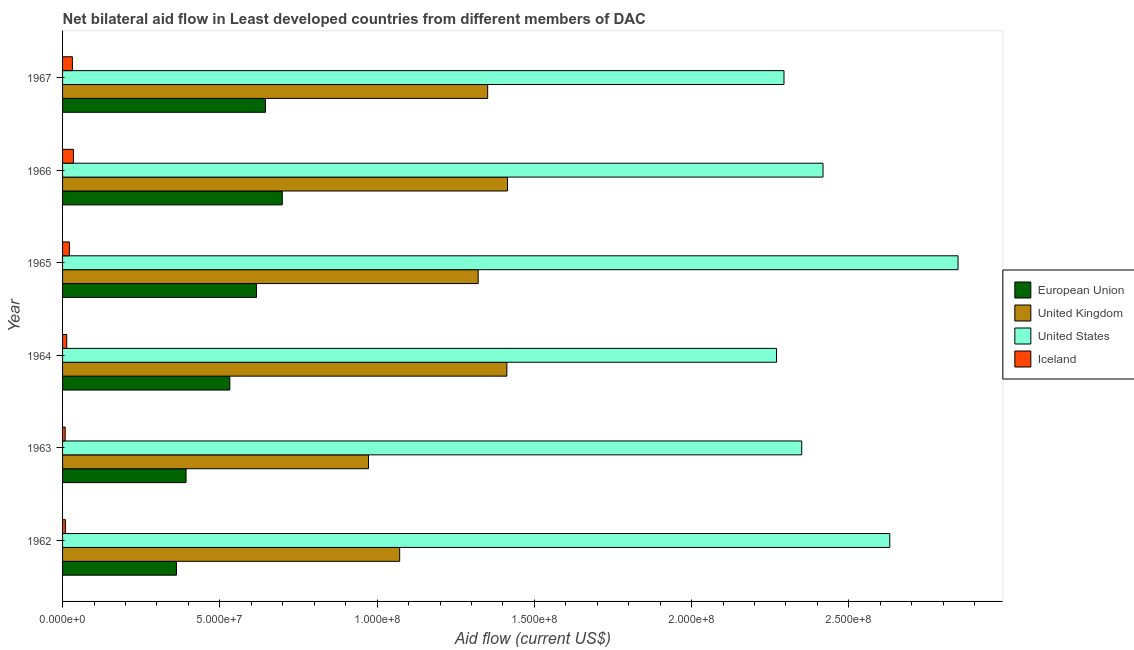How many groups of bars are there?
Make the answer very short. 6. What is the label of the 1st group of bars from the top?
Your answer should be very brief. 1967. In how many cases, is the number of bars for a given year not equal to the number of legend labels?
Make the answer very short. 0. What is the amount of aid given by uk in 1965?
Your response must be concise. 1.32e+08. Across all years, what is the maximum amount of aid given by eu?
Provide a short and direct response. 6.99e+07. Across all years, what is the minimum amount of aid given by iceland?
Make the answer very short. 8.30e+05. In which year was the amount of aid given by us maximum?
Give a very brief answer. 1965. In which year was the amount of aid given by iceland minimum?
Your answer should be very brief. 1963. What is the total amount of aid given by uk in the graph?
Your answer should be compact. 7.54e+08. What is the difference between the amount of aid given by uk in 1963 and that in 1967?
Give a very brief answer. -3.79e+07. What is the difference between the amount of aid given by us in 1965 and the amount of aid given by eu in 1963?
Give a very brief answer. 2.45e+08. What is the average amount of aid given by us per year?
Provide a succinct answer. 2.47e+08. In the year 1962, what is the difference between the amount of aid given by uk and amount of aid given by eu?
Your answer should be very brief. 7.10e+07. In how many years, is the amount of aid given by uk greater than 200000000 US$?
Your response must be concise. 0. What is the ratio of the amount of aid given by iceland in 1964 to that in 1967?
Offer a very short reply. 0.43. Is the amount of aid given by iceland in 1963 less than that in 1964?
Give a very brief answer. Yes. What is the difference between the highest and the second highest amount of aid given by eu?
Your answer should be very brief. 5.35e+06. What is the difference between the highest and the lowest amount of aid given by eu?
Provide a succinct answer. 3.36e+07. In how many years, is the amount of aid given by iceland greater than the average amount of aid given by iceland taken over all years?
Keep it short and to the point. 3. Is the sum of the amount of aid given by iceland in 1963 and 1967 greater than the maximum amount of aid given by uk across all years?
Your response must be concise. No. What does the 2nd bar from the top in 1967 represents?
Your answer should be compact. United States. Is it the case that in every year, the sum of the amount of aid given by eu and amount of aid given by uk is greater than the amount of aid given by us?
Provide a short and direct response. No. Are all the bars in the graph horizontal?
Give a very brief answer. Yes. What is the difference between two consecutive major ticks on the X-axis?
Make the answer very short. 5.00e+07. Does the graph contain any zero values?
Your response must be concise. No. Where does the legend appear in the graph?
Your answer should be compact. Center right. How many legend labels are there?
Keep it short and to the point. 4. How are the legend labels stacked?
Your answer should be very brief. Vertical. What is the title of the graph?
Make the answer very short. Net bilateral aid flow in Least developed countries from different members of DAC. Does "UNHCR" appear as one of the legend labels in the graph?
Provide a succinct answer. No. What is the Aid flow (current US$) in European Union in 1962?
Your response must be concise. 3.62e+07. What is the Aid flow (current US$) of United Kingdom in 1962?
Make the answer very short. 1.07e+08. What is the Aid flow (current US$) of United States in 1962?
Make the answer very short. 2.63e+08. What is the Aid flow (current US$) in European Union in 1963?
Provide a succinct answer. 3.93e+07. What is the Aid flow (current US$) in United Kingdom in 1963?
Provide a short and direct response. 9.73e+07. What is the Aid flow (current US$) of United States in 1963?
Provide a short and direct response. 2.35e+08. What is the Aid flow (current US$) of Iceland in 1963?
Keep it short and to the point. 8.30e+05. What is the Aid flow (current US$) in European Union in 1964?
Your answer should be very brief. 5.32e+07. What is the Aid flow (current US$) in United Kingdom in 1964?
Ensure brevity in your answer.  1.41e+08. What is the Aid flow (current US$) in United States in 1964?
Make the answer very short. 2.27e+08. What is the Aid flow (current US$) in Iceland in 1964?
Your answer should be compact. 1.33e+06. What is the Aid flow (current US$) of European Union in 1965?
Offer a terse response. 6.16e+07. What is the Aid flow (current US$) in United Kingdom in 1965?
Offer a terse response. 1.32e+08. What is the Aid flow (current US$) in United States in 1965?
Make the answer very short. 2.85e+08. What is the Aid flow (current US$) in Iceland in 1965?
Your response must be concise. 2.18e+06. What is the Aid flow (current US$) in European Union in 1966?
Ensure brevity in your answer.  6.99e+07. What is the Aid flow (current US$) of United Kingdom in 1966?
Keep it short and to the point. 1.41e+08. What is the Aid flow (current US$) in United States in 1966?
Your answer should be very brief. 2.42e+08. What is the Aid flow (current US$) in Iceland in 1966?
Make the answer very short. 3.46e+06. What is the Aid flow (current US$) of European Union in 1967?
Give a very brief answer. 6.45e+07. What is the Aid flow (current US$) in United Kingdom in 1967?
Give a very brief answer. 1.35e+08. What is the Aid flow (current US$) of United States in 1967?
Offer a terse response. 2.29e+08. What is the Aid flow (current US$) in Iceland in 1967?
Your answer should be very brief. 3.12e+06. Across all years, what is the maximum Aid flow (current US$) of European Union?
Offer a very short reply. 6.99e+07. Across all years, what is the maximum Aid flow (current US$) in United Kingdom?
Offer a terse response. 1.41e+08. Across all years, what is the maximum Aid flow (current US$) in United States?
Offer a terse response. 2.85e+08. Across all years, what is the maximum Aid flow (current US$) of Iceland?
Make the answer very short. 3.46e+06. Across all years, what is the minimum Aid flow (current US$) of European Union?
Make the answer very short. 3.62e+07. Across all years, what is the minimum Aid flow (current US$) of United Kingdom?
Provide a short and direct response. 9.73e+07. Across all years, what is the minimum Aid flow (current US$) in United States?
Offer a very short reply. 2.27e+08. Across all years, what is the minimum Aid flow (current US$) in Iceland?
Provide a succinct answer. 8.30e+05. What is the total Aid flow (current US$) in European Union in the graph?
Keep it short and to the point. 3.25e+08. What is the total Aid flow (current US$) of United Kingdom in the graph?
Your answer should be very brief. 7.54e+08. What is the total Aid flow (current US$) in United States in the graph?
Offer a very short reply. 1.48e+09. What is the total Aid flow (current US$) of Iceland in the graph?
Your answer should be compact. 1.18e+07. What is the difference between the Aid flow (current US$) in European Union in 1962 and that in 1963?
Your answer should be compact. -3.05e+06. What is the difference between the Aid flow (current US$) in United Kingdom in 1962 and that in 1963?
Your answer should be very brief. 9.91e+06. What is the difference between the Aid flow (current US$) of United States in 1962 and that in 1963?
Provide a short and direct response. 2.80e+07. What is the difference between the Aid flow (current US$) of Iceland in 1962 and that in 1963?
Provide a succinct answer. 7.00e+04. What is the difference between the Aid flow (current US$) in European Union in 1962 and that in 1964?
Offer a terse response. -1.70e+07. What is the difference between the Aid flow (current US$) in United Kingdom in 1962 and that in 1964?
Your answer should be compact. -3.41e+07. What is the difference between the Aid flow (current US$) of United States in 1962 and that in 1964?
Offer a very short reply. 3.60e+07. What is the difference between the Aid flow (current US$) of Iceland in 1962 and that in 1964?
Offer a very short reply. -4.30e+05. What is the difference between the Aid flow (current US$) of European Union in 1962 and that in 1965?
Provide a succinct answer. -2.54e+07. What is the difference between the Aid flow (current US$) of United Kingdom in 1962 and that in 1965?
Offer a very short reply. -2.50e+07. What is the difference between the Aid flow (current US$) in United States in 1962 and that in 1965?
Offer a very short reply. -2.17e+07. What is the difference between the Aid flow (current US$) in Iceland in 1962 and that in 1965?
Ensure brevity in your answer.  -1.28e+06. What is the difference between the Aid flow (current US$) in European Union in 1962 and that in 1966?
Your response must be concise. -3.36e+07. What is the difference between the Aid flow (current US$) in United Kingdom in 1962 and that in 1966?
Keep it short and to the point. -3.43e+07. What is the difference between the Aid flow (current US$) of United States in 1962 and that in 1966?
Your answer should be very brief. 2.12e+07. What is the difference between the Aid flow (current US$) of Iceland in 1962 and that in 1966?
Make the answer very short. -2.56e+06. What is the difference between the Aid flow (current US$) of European Union in 1962 and that in 1967?
Give a very brief answer. -2.83e+07. What is the difference between the Aid flow (current US$) in United Kingdom in 1962 and that in 1967?
Your answer should be compact. -2.80e+07. What is the difference between the Aid flow (current US$) in United States in 1962 and that in 1967?
Make the answer very short. 3.36e+07. What is the difference between the Aid flow (current US$) in Iceland in 1962 and that in 1967?
Your answer should be very brief. -2.22e+06. What is the difference between the Aid flow (current US$) in European Union in 1963 and that in 1964?
Offer a terse response. -1.39e+07. What is the difference between the Aid flow (current US$) of United Kingdom in 1963 and that in 1964?
Provide a short and direct response. -4.40e+07. What is the difference between the Aid flow (current US$) in Iceland in 1963 and that in 1964?
Give a very brief answer. -5.00e+05. What is the difference between the Aid flow (current US$) of European Union in 1963 and that in 1965?
Offer a very short reply. -2.24e+07. What is the difference between the Aid flow (current US$) in United Kingdom in 1963 and that in 1965?
Offer a terse response. -3.49e+07. What is the difference between the Aid flow (current US$) in United States in 1963 and that in 1965?
Make the answer very short. -4.97e+07. What is the difference between the Aid flow (current US$) of Iceland in 1963 and that in 1965?
Offer a terse response. -1.35e+06. What is the difference between the Aid flow (current US$) in European Union in 1963 and that in 1966?
Your answer should be very brief. -3.06e+07. What is the difference between the Aid flow (current US$) of United Kingdom in 1963 and that in 1966?
Your answer should be compact. -4.42e+07. What is the difference between the Aid flow (current US$) in United States in 1963 and that in 1966?
Give a very brief answer. -6.78e+06. What is the difference between the Aid flow (current US$) of Iceland in 1963 and that in 1966?
Provide a succinct answer. -2.63e+06. What is the difference between the Aid flow (current US$) of European Union in 1963 and that in 1967?
Provide a short and direct response. -2.52e+07. What is the difference between the Aid flow (current US$) of United Kingdom in 1963 and that in 1967?
Your answer should be compact. -3.79e+07. What is the difference between the Aid flow (current US$) in United States in 1963 and that in 1967?
Provide a short and direct response. 5.63e+06. What is the difference between the Aid flow (current US$) in Iceland in 1963 and that in 1967?
Ensure brevity in your answer.  -2.29e+06. What is the difference between the Aid flow (current US$) in European Union in 1964 and that in 1965?
Your response must be concise. -8.46e+06. What is the difference between the Aid flow (current US$) of United Kingdom in 1964 and that in 1965?
Your response must be concise. 9.12e+06. What is the difference between the Aid flow (current US$) in United States in 1964 and that in 1965?
Make the answer very short. -5.77e+07. What is the difference between the Aid flow (current US$) in Iceland in 1964 and that in 1965?
Provide a succinct answer. -8.50e+05. What is the difference between the Aid flow (current US$) in European Union in 1964 and that in 1966?
Provide a short and direct response. -1.67e+07. What is the difference between the Aid flow (current US$) in United States in 1964 and that in 1966?
Your response must be concise. -1.48e+07. What is the difference between the Aid flow (current US$) of Iceland in 1964 and that in 1966?
Give a very brief answer. -2.13e+06. What is the difference between the Aid flow (current US$) in European Union in 1964 and that in 1967?
Give a very brief answer. -1.13e+07. What is the difference between the Aid flow (current US$) of United Kingdom in 1964 and that in 1967?
Ensure brevity in your answer.  6.10e+06. What is the difference between the Aid flow (current US$) in United States in 1964 and that in 1967?
Your answer should be compact. -2.37e+06. What is the difference between the Aid flow (current US$) in Iceland in 1964 and that in 1967?
Ensure brevity in your answer.  -1.79e+06. What is the difference between the Aid flow (current US$) of European Union in 1965 and that in 1966?
Your answer should be very brief. -8.22e+06. What is the difference between the Aid flow (current US$) in United Kingdom in 1965 and that in 1966?
Provide a succinct answer. -9.33e+06. What is the difference between the Aid flow (current US$) of United States in 1965 and that in 1966?
Offer a very short reply. 4.29e+07. What is the difference between the Aid flow (current US$) in Iceland in 1965 and that in 1966?
Provide a short and direct response. -1.28e+06. What is the difference between the Aid flow (current US$) in European Union in 1965 and that in 1967?
Your response must be concise. -2.87e+06. What is the difference between the Aid flow (current US$) of United Kingdom in 1965 and that in 1967?
Ensure brevity in your answer.  -3.02e+06. What is the difference between the Aid flow (current US$) of United States in 1965 and that in 1967?
Give a very brief answer. 5.53e+07. What is the difference between the Aid flow (current US$) of Iceland in 1965 and that in 1967?
Offer a terse response. -9.40e+05. What is the difference between the Aid flow (current US$) in European Union in 1966 and that in 1967?
Keep it short and to the point. 5.35e+06. What is the difference between the Aid flow (current US$) in United Kingdom in 1966 and that in 1967?
Provide a short and direct response. 6.31e+06. What is the difference between the Aid flow (current US$) of United States in 1966 and that in 1967?
Your response must be concise. 1.24e+07. What is the difference between the Aid flow (current US$) of European Union in 1962 and the Aid flow (current US$) of United Kingdom in 1963?
Ensure brevity in your answer.  -6.11e+07. What is the difference between the Aid flow (current US$) in European Union in 1962 and the Aid flow (current US$) in United States in 1963?
Ensure brevity in your answer.  -1.99e+08. What is the difference between the Aid flow (current US$) in European Union in 1962 and the Aid flow (current US$) in Iceland in 1963?
Your answer should be compact. 3.54e+07. What is the difference between the Aid flow (current US$) of United Kingdom in 1962 and the Aid flow (current US$) of United States in 1963?
Ensure brevity in your answer.  -1.28e+08. What is the difference between the Aid flow (current US$) in United Kingdom in 1962 and the Aid flow (current US$) in Iceland in 1963?
Provide a succinct answer. 1.06e+08. What is the difference between the Aid flow (current US$) of United States in 1962 and the Aid flow (current US$) of Iceland in 1963?
Keep it short and to the point. 2.62e+08. What is the difference between the Aid flow (current US$) in European Union in 1962 and the Aid flow (current US$) in United Kingdom in 1964?
Give a very brief answer. -1.05e+08. What is the difference between the Aid flow (current US$) of European Union in 1962 and the Aid flow (current US$) of United States in 1964?
Give a very brief answer. -1.91e+08. What is the difference between the Aid flow (current US$) in European Union in 1962 and the Aid flow (current US$) in Iceland in 1964?
Your answer should be very brief. 3.49e+07. What is the difference between the Aid flow (current US$) in United Kingdom in 1962 and the Aid flow (current US$) in United States in 1964?
Provide a short and direct response. -1.20e+08. What is the difference between the Aid flow (current US$) of United Kingdom in 1962 and the Aid flow (current US$) of Iceland in 1964?
Keep it short and to the point. 1.06e+08. What is the difference between the Aid flow (current US$) in United States in 1962 and the Aid flow (current US$) in Iceland in 1964?
Your response must be concise. 2.62e+08. What is the difference between the Aid flow (current US$) in European Union in 1962 and the Aid flow (current US$) in United Kingdom in 1965?
Provide a succinct answer. -9.59e+07. What is the difference between the Aid flow (current US$) of European Union in 1962 and the Aid flow (current US$) of United States in 1965?
Your answer should be very brief. -2.48e+08. What is the difference between the Aid flow (current US$) in European Union in 1962 and the Aid flow (current US$) in Iceland in 1965?
Offer a very short reply. 3.40e+07. What is the difference between the Aid flow (current US$) in United Kingdom in 1962 and the Aid flow (current US$) in United States in 1965?
Your response must be concise. -1.78e+08. What is the difference between the Aid flow (current US$) in United Kingdom in 1962 and the Aid flow (current US$) in Iceland in 1965?
Your answer should be very brief. 1.05e+08. What is the difference between the Aid flow (current US$) of United States in 1962 and the Aid flow (current US$) of Iceland in 1965?
Make the answer very short. 2.61e+08. What is the difference between the Aid flow (current US$) in European Union in 1962 and the Aid flow (current US$) in United Kingdom in 1966?
Provide a short and direct response. -1.05e+08. What is the difference between the Aid flow (current US$) of European Union in 1962 and the Aid flow (current US$) of United States in 1966?
Ensure brevity in your answer.  -2.06e+08. What is the difference between the Aid flow (current US$) of European Union in 1962 and the Aid flow (current US$) of Iceland in 1966?
Provide a succinct answer. 3.28e+07. What is the difference between the Aid flow (current US$) in United Kingdom in 1962 and the Aid flow (current US$) in United States in 1966?
Offer a terse response. -1.35e+08. What is the difference between the Aid flow (current US$) of United Kingdom in 1962 and the Aid flow (current US$) of Iceland in 1966?
Provide a short and direct response. 1.04e+08. What is the difference between the Aid flow (current US$) of United States in 1962 and the Aid flow (current US$) of Iceland in 1966?
Offer a terse response. 2.60e+08. What is the difference between the Aid flow (current US$) of European Union in 1962 and the Aid flow (current US$) of United Kingdom in 1967?
Offer a terse response. -9.90e+07. What is the difference between the Aid flow (current US$) in European Union in 1962 and the Aid flow (current US$) in United States in 1967?
Provide a short and direct response. -1.93e+08. What is the difference between the Aid flow (current US$) of European Union in 1962 and the Aid flow (current US$) of Iceland in 1967?
Offer a very short reply. 3.31e+07. What is the difference between the Aid flow (current US$) of United Kingdom in 1962 and the Aid flow (current US$) of United States in 1967?
Your response must be concise. -1.22e+08. What is the difference between the Aid flow (current US$) of United Kingdom in 1962 and the Aid flow (current US$) of Iceland in 1967?
Offer a very short reply. 1.04e+08. What is the difference between the Aid flow (current US$) of United States in 1962 and the Aid flow (current US$) of Iceland in 1967?
Keep it short and to the point. 2.60e+08. What is the difference between the Aid flow (current US$) of European Union in 1963 and the Aid flow (current US$) of United Kingdom in 1964?
Make the answer very short. -1.02e+08. What is the difference between the Aid flow (current US$) in European Union in 1963 and the Aid flow (current US$) in United States in 1964?
Provide a succinct answer. -1.88e+08. What is the difference between the Aid flow (current US$) of European Union in 1963 and the Aid flow (current US$) of Iceland in 1964?
Make the answer very short. 3.79e+07. What is the difference between the Aid flow (current US$) in United Kingdom in 1963 and the Aid flow (current US$) in United States in 1964?
Your response must be concise. -1.30e+08. What is the difference between the Aid flow (current US$) in United Kingdom in 1963 and the Aid flow (current US$) in Iceland in 1964?
Make the answer very short. 9.59e+07. What is the difference between the Aid flow (current US$) in United States in 1963 and the Aid flow (current US$) in Iceland in 1964?
Keep it short and to the point. 2.34e+08. What is the difference between the Aid flow (current US$) in European Union in 1963 and the Aid flow (current US$) in United Kingdom in 1965?
Keep it short and to the point. -9.29e+07. What is the difference between the Aid flow (current US$) in European Union in 1963 and the Aid flow (current US$) in United States in 1965?
Offer a very short reply. -2.45e+08. What is the difference between the Aid flow (current US$) in European Union in 1963 and the Aid flow (current US$) in Iceland in 1965?
Your answer should be very brief. 3.71e+07. What is the difference between the Aid flow (current US$) in United Kingdom in 1963 and the Aid flow (current US$) in United States in 1965?
Offer a terse response. -1.87e+08. What is the difference between the Aid flow (current US$) in United Kingdom in 1963 and the Aid flow (current US$) in Iceland in 1965?
Provide a short and direct response. 9.51e+07. What is the difference between the Aid flow (current US$) in United States in 1963 and the Aid flow (current US$) in Iceland in 1965?
Ensure brevity in your answer.  2.33e+08. What is the difference between the Aid flow (current US$) in European Union in 1963 and the Aid flow (current US$) in United Kingdom in 1966?
Your answer should be compact. -1.02e+08. What is the difference between the Aid flow (current US$) in European Union in 1963 and the Aid flow (current US$) in United States in 1966?
Your answer should be very brief. -2.03e+08. What is the difference between the Aid flow (current US$) of European Union in 1963 and the Aid flow (current US$) of Iceland in 1966?
Ensure brevity in your answer.  3.58e+07. What is the difference between the Aid flow (current US$) in United Kingdom in 1963 and the Aid flow (current US$) in United States in 1966?
Offer a terse response. -1.45e+08. What is the difference between the Aid flow (current US$) of United Kingdom in 1963 and the Aid flow (current US$) of Iceland in 1966?
Your answer should be compact. 9.38e+07. What is the difference between the Aid flow (current US$) of United States in 1963 and the Aid flow (current US$) of Iceland in 1966?
Offer a terse response. 2.32e+08. What is the difference between the Aid flow (current US$) in European Union in 1963 and the Aid flow (current US$) in United Kingdom in 1967?
Your answer should be compact. -9.59e+07. What is the difference between the Aid flow (current US$) of European Union in 1963 and the Aid flow (current US$) of United States in 1967?
Keep it short and to the point. -1.90e+08. What is the difference between the Aid flow (current US$) in European Union in 1963 and the Aid flow (current US$) in Iceland in 1967?
Ensure brevity in your answer.  3.61e+07. What is the difference between the Aid flow (current US$) of United Kingdom in 1963 and the Aid flow (current US$) of United States in 1967?
Your response must be concise. -1.32e+08. What is the difference between the Aid flow (current US$) in United Kingdom in 1963 and the Aid flow (current US$) in Iceland in 1967?
Offer a terse response. 9.42e+07. What is the difference between the Aid flow (current US$) of United States in 1963 and the Aid flow (current US$) of Iceland in 1967?
Your response must be concise. 2.32e+08. What is the difference between the Aid flow (current US$) in European Union in 1964 and the Aid flow (current US$) in United Kingdom in 1965?
Offer a very short reply. -7.90e+07. What is the difference between the Aid flow (current US$) in European Union in 1964 and the Aid flow (current US$) in United States in 1965?
Your answer should be very brief. -2.32e+08. What is the difference between the Aid flow (current US$) of European Union in 1964 and the Aid flow (current US$) of Iceland in 1965?
Your answer should be compact. 5.10e+07. What is the difference between the Aid flow (current US$) in United Kingdom in 1964 and the Aid flow (current US$) in United States in 1965?
Provide a succinct answer. -1.43e+08. What is the difference between the Aid flow (current US$) in United Kingdom in 1964 and the Aid flow (current US$) in Iceland in 1965?
Give a very brief answer. 1.39e+08. What is the difference between the Aid flow (current US$) of United States in 1964 and the Aid flow (current US$) of Iceland in 1965?
Your answer should be compact. 2.25e+08. What is the difference between the Aid flow (current US$) in European Union in 1964 and the Aid flow (current US$) in United Kingdom in 1966?
Ensure brevity in your answer.  -8.83e+07. What is the difference between the Aid flow (current US$) of European Union in 1964 and the Aid flow (current US$) of United States in 1966?
Offer a very short reply. -1.89e+08. What is the difference between the Aid flow (current US$) of European Union in 1964 and the Aid flow (current US$) of Iceland in 1966?
Provide a short and direct response. 4.97e+07. What is the difference between the Aid flow (current US$) in United Kingdom in 1964 and the Aid flow (current US$) in United States in 1966?
Make the answer very short. -1.01e+08. What is the difference between the Aid flow (current US$) of United Kingdom in 1964 and the Aid flow (current US$) of Iceland in 1966?
Ensure brevity in your answer.  1.38e+08. What is the difference between the Aid flow (current US$) of United States in 1964 and the Aid flow (current US$) of Iceland in 1966?
Provide a short and direct response. 2.24e+08. What is the difference between the Aid flow (current US$) in European Union in 1964 and the Aid flow (current US$) in United Kingdom in 1967?
Make the answer very short. -8.20e+07. What is the difference between the Aid flow (current US$) of European Union in 1964 and the Aid flow (current US$) of United States in 1967?
Provide a succinct answer. -1.76e+08. What is the difference between the Aid flow (current US$) of European Union in 1964 and the Aid flow (current US$) of Iceland in 1967?
Provide a short and direct response. 5.01e+07. What is the difference between the Aid flow (current US$) of United Kingdom in 1964 and the Aid flow (current US$) of United States in 1967?
Ensure brevity in your answer.  -8.81e+07. What is the difference between the Aid flow (current US$) of United Kingdom in 1964 and the Aid flow (current US$) of Iceland in 1967?
Offer a very short reply. 1.38e+08. What is the difference between the Aid flow (current US$) in United States in 1964 and the Aid flow (current US$) in Iceland in 1967?
Your answer should be very brief. 2.24e+08. What is the difference between the Aid flow (current US$) of European Union in 1965 and the Aid flow (current US$) of United Kingdom in 1966?
Offer a very short reply. -7.98e+07. What is the difference between the Aid flow (current US$) of European Union in 1965 and the Aid flow (current US$) of United States in 1966?
Provide a short and direct response. -1.80e+08. What is the difference between the Aid flow (current US$) of European Union in 1965 and the Aid flow (current US$) of Iceland in 1966?
Give a very brief answer. 5.82e+07. What is the difference between the Aid flow (current US$) of United Kingdom in 1965 and the Aid flow (current US$) of United States in 1966?
Provide a short and direct response. -1.10e+08. What is the difference between the Aid flow (current US$) in United Kingdom in 1965 and the Aid flow (current US$) in Iceland in 1966?
Provide a succinct answer. 1.29e+08. What is the difference between the Aid flow (current US$) of United States in 1965 and the Aid flow (current US$) of Iceland in 1966?
Provide a succinct answer. 2.81e+08. What is the difference between the Aid flow (current US$) of European Union in 1965 and the Aid flow (current US$) of United Kingdom in 1967?
Give a very brief answer. -7.35e+07. What is the difference between the Aid flow (current US$) of European Union in 1965 and the Aid flow (current US$) of United States in 1967?
Provide a succinct answer. -1.68e+08. What is the difference between the Aid flow (current US$) of European Union in 1965 and the Aid flow (current US$) of Iceland in 1967?
Your response must be concise. 5.85e+07. What is the difference between the Aid flow (current US$) of United Kingdom in 1965 and the Aid flow (current US$) of United States in 1967?
Make the answer very short. -9.72e+07. What is the difference between the Aid flow (current US$) in United Kingdom in 1965 and the Aid flow (current US$) in Iceland in 1967?
Give a very brief answer. 1.29e+08. What is the difference between the Aid flow (current US$) in United States in 1965 and the Aid flow (current US$) in Iceland in 1967?
Give a very brief answer. 2.82e+08. What is the difference between the Aid flow (current US$) in European Union in 1966 and the Aid flow (current US$) in United Kingdom in 1967?
Offer a very short reply. -6.53e+07. What is the difference between the Aid flow (current US$) in European Union in 1966 and the Aid flow (current US$) in United States in 1967?
Give a very brief answer. -1.60e+08. What is the difference between the Aid flow (current US$) of European Union in 1966 and the Aid flow (current US$) of Iceland in 1967?
Offer a terse response. 6.67e+07. What is the difference between the Aid flow (current US$) in United Kingdom in 1966 and the Aid flow (current US$) in United States in 1967?
Your answer should be compact. -8.79e+07. What is the difference between the Aid flow (current US$) of United Kingdom in 1966 and the Aid flow (current US$) of Iceland in 1967?
Your response must be concise. 1.38e+08. What is the difference between the Aid flow (current US$) of United States in 1966 and the Aid flow (current US$) of Iceland in 1967?
Your answer should be compact. 2.39e+08. What is the average Aid flow (current US$) in European Union per year?
Offer a terse response. 5.41e+07. What is the average Aid flow (current US$) of United Kingdom per year?
Keep it short and to the point. 1.26e+08. What is the average Aid flow (current US$) in United States per year?
Your response must be concise. 2.47e+08. What is the average Aid flow (current US$) of Iceland per year?
Provide a succinct answer. 1.97e+06. In the year 1962, what is the difference between the Aid flow (current US$) of European Union and Aid flow (current US$) of United Kingdom?
Keep it short and to the point. -7.10e+07. In the year 1962, what is the difference between the Aid flow (current US$) in European Union and Aid flow (current US$) in United States?
Offer a terse response. -2.27e+08. In the year 1962, what is the difference between the Aid flow (current US$) in European Union and Aid flow (current US$) in Iceland?
Keep it short and to the point. 3.53e+07. In the year 1962, what is the difference between the Aid flow (current US$) of United Kingdom and Aid flow (current US$) of United States?
Provide a succinct answer. -1.56e+08. In the year 1962, what is the difference between the Aid flow (current US$) of United Kingdom and Aid flow (current US$) of Iceland?
Offer a very short reply. 1.06e+08. In the year 1962, what is the difference between the Aid flow (current US$) of United States and Aid flow (current US$) of Iceland?
Your answer should be compact. 2.62e+08. In the year 1963, what is the difference between the Aid flow (current US$) of European Union and Aid flow (current US$) of United Kingdom?
Offer a terse response. -5.80e+07. In the year 1963, what is the difference between the Aid flow (current US$) of European Union and Aid flow (current US$) of United States?
Provide a succinct answer. -1.96e+08. In the year 1963, what is the difference between the Aid flow (current US$) of European Union and Aid flow (current US$) of Iceland?
Provide a short and direct response. 3.84e+07. In the year 1963, what is the difference between the Aid flow (current US$) of United Kingdom and Aid flow (current US$) of United States?
Keep it short and to the point. -1.38e+08. In the year 1963, what is the difference between the Aid flow (current US$) of United Kingdom and Aid flow (current US$) of Iceland?
Provide a succinct answer. 9.64e+07. In the year 1963, what is the difference between the Aid flow (current US$) of United States and Aid flow (current US$) of Iceland?
Ensure brevity in your answer.  2.34e+08. In the year 1964, what is the difference between the Aid flow (current US$) of European Union and Aid flow (current US$) of United Kingdom?
Your response must be concise. -8.81e+07. In the year 1964, what is the difference between the Aid flow (current US$) in European Union and Aid flow (current US$) in United States?
Your response must be concise. -1.74e+08. In the year 1964, what is the difference between the Aid flow (current US$) of European Union and Aid flow (current US$) of Iceland?
Give a very brief answer. 5.18e+07. In the year 1964, what is the difference between the Aid flow (current US$) in United Kingdom and Aid flow (current US$) in United States?
Your answer should be compact. -8.57e+07. In the year 1964, what is the difference between the Aid flow (current US$) of United Kingdom and Aid flow (current US$) of Iceland?
Your answer should be very brief. 1.40e+08. In the year 1964, what is the difference between the Aid flow (current US$) of United States and Aid flow (current US$) of Iceland?
Your response must be concise. 2.26e+08. In the year 1965, what is the difference between the Aid flow (current US$) in European Union and Aid flow (current US$) in United Kingdom?
Give a very brief answer. -7.05e+07. In the year 1965, what is the difference between the Aid flow (current US$) of European Union and Aid flow (current US$) of United States?
Give a very brief answer. -2.23e+08. In the year 1965, what is the difference between the Aid flow (current US$) of European Union and Aid flow (current US$) of Iceland?
Give a very brief answer. 5.95e+07. In the year 1965, what is the difference between the Aid flow (current US$) of United Kingdom and Aid flow (current US$) of United States?
Ensure brevity in your answer.  -1.53e+08. In the year 1965, what is the difference between the Aid flow (current US$) of United Kingdom and Aid flow (current US$) of Iceland?
Offer a terse response. 1.30e+08. In the year 1965, what is the difference between the Aid flow (current US$) of United States and Aid flow (current US$) of Iceland?
Provide a short and direct response. 2.83e+08. In the year 1966, what is the difference between the Aid flow (current US$) of European Union and Aid flow (current US$) of United Kingdom?
Ensure brevity in your answer.  -7.16e+07. In the year 1966, what is the difference between the Aid flow (current US$) of European Union and Aid flow (current US$) of United States?
Offer a terse response. -1.72e+08. In the year 1966, what is the difference between the Aid flow (current US$) of European Union and Aid flow (current US$) of Iceland?
Keep it short and to the point. 6.64e+07. In the year 1966, what is the difference between the Aid flow (current US$) of United Kingdom and Aid flow (current US$) of United States?
Keep it short and to the point. -1.00e+08. In the year 1966, what is the difference between the Aid flow (current US$) in United Kingdom and Aid flow (current US$) in Iceland?
Your answer should be compact. 1.38e+08. In the year 1966, what is the difference between the Aid flow (current US$) of United States and Aid flow (current US$) of Iceland?
Give a very brief answer. 2.38e+08. In the year 1967, what is the difference between the Aid flow (current US$) of European Union and Aid flow (current US$) of United Kingdom?
Ensure brevity in your answer.  -7.06e+07. In the year 1967, what is the difference between the Aid flow (current US$) in European Union and Aid flow (current US$) in United States?
Make the answer very short. -1.65e+08. In the year 1967, what is the difference between the Aid flow (current US$) of European Union and Aid flow (current US$) of Iceland?
Ensure brevity in your answer.  6.14e+07. In the year 1967, what is the difference between the Aid flow (current US$) in United Kingdom and Aid flow (current US$) in United States?
Make the answer very short. -9.42e+07. In the year 1967, what is the difference between the Aid flow (current US$) in United Kingdom and Aid flow (current US$) in Iceland?
Offer a very short reply. 1.32e+08. In the year 1967, what is the difference between the Aid flow (current US$) in United States and Aid flow (current US$) in Iceland?
Give a very brief answer. 2.26e+08. What is the ratio of the Aid flow (current US$) in European Union in 1962 to that in 1963?
Offer a very short reply. 0.92. What is the ratio of the Aid flow (current US$) in United Kingdom in 1962 to that in 1963?
Provide a succinct answer. 1.1. What is the ratio of the Aid flow (current US$) in United States in 1962 to that in 1963?
Make the answer very short. 1.12. What is the ratio of the Aid flow (current US$) in Iceland in 1962 to that in 1963?
Offer a terse response. 1.08. What is the ratio of the Aid flow (current US$) of European Union in 1962 to that in 1964?
Your answer should be compact. 0.68. What is the ratio of the Aid flow (current US$) of United Kingdom in 1962 to that in 1964?
Your answer should be compact. 0.76. What is the ratio of the Aid flow (current US$) in United States in 1962 to that in 1964?
Ensure brevity in your answer.  1.16. What is the ratio of the Aid flow (current US$) in Iceland in 1962 to that in 1964?
Your answer should be very brief. 0.68. What is the ratio of the Aid flow (current US$) in European Union in 1962 to that in 1965?
Offer a very short reply. 0.59. What is the ratio of the Aid flow (current US$) of United Kingdom in 1962 to that in 1965?
Provide a short and direct response. 0.81. What is the ratio of the Aid flow (current US$) in United States in 1962 to that in 1965?
Make the answer very short. 0.92. What is the ratio of the Aid flow (current US$) of Iceland in 1962 to that in 1965?
Give a very brief answer. 0.41. What is the ratio of the Aid flow (current US$) in European Union in 1962 to that in 1966?
Give a very brief answer. 0.52. What is the ratio of the Aid flow (current US$) of United Kingdom in 1962 to that in 1966?
Keep it short and to the point. 0.76. What is the ratio of the Aid flow (current US$) of United States in 1962 to that in 1966?
Give a very brief answer. 1.09. What is the ratio of the Aid flow (current US$) in Iceland in 1962 to that in 1966?
Ensure brevity in your answer.  0.26. What is the ratio of the Aid flow (current US$) of European Union in 1962 to that in 1967?
Make the answer very short. 0.56. What is the ratio of the Aid flow (current US$) of United Kingdom in 1962 to that in 1967?
Your answer should be very brief. 0.79. What is the ratio of the Aid flow (current US$) in United States in 1962 to that in 1967?
Ensure brevity in your answer.  1.15. What is the ratio of the Aid flow (current US$) of Iceland in 1962 to that in 1967?
Make the answer very short. 0.29. What is the ratio of the Aid flow (current US$) in European Union in 1963 to that in 1964?
Offer a terse response. 0.74. What is the ratio of the Aid flow (current US$) of United Kingdom in 1963 to that in 1964?
Give a very brief answer. 0.69. What is the ratio of the Aid flow (current US$) of United States in 1963 to that in 1964?
Provide a short and direct response. 1.04. What is the ratio of the Aid flow (current US$) of Iceland in 1963 to that in 1964?
Your answer should be compact. 0.62. What is the ratio of the Aid flow (current US$) of European Union in 1963 to that in 1965?
Offer a terse response. 0.64. What is the ratio of the Aid flow (current US$) of United Kingdom in 1963 to that in 1965?
Your response must be concise. 0.74. What is the ratio of the Aid flow (current US$) of United States in 1963 to that in 1965?
Provide a short and direct response. 0.83. What is the ratio of the Aid flow (current US$) of Iceland in 1963 to that in 1965?
Ensure brevity in your answer.  0.38. What is the ratio of the Aid flow (current US$) in European Union in 1963 to that in 1966?
Provide a short and direct response. 0.56. What is the ratio of the Aid flow (current US$) of United Kingdom in 1963 to that in 1966?
Offer a terse response. 0.69. What is the ratio of the Aid flow (current US$) of Iceland in 1963 to that in 1966?
Offer a terse response. 0.24. What is the ratio of the Aid flow (current US$) in European Union in 1963 to that in 1967?
Your answer should be very brief. 0.61. What is the ratio of the Aid flow (current US$) of United Kingdom in 1963 to that in 1967?
Make the answer very short. 0.72. What is the ratio of the Aid flow (current US$) in United States in 1963 to that in 1967?
Provide a short and direct response. 1.02. What is the ratio of the Aid flow (current US$) of Iceland in 1963 to that in 1967?
Give a very brief answer. 0.27. What is the ratio of the Aid flow (current US$) in European Union in 1964 to that in 1965?
Offer a terse response. 0.86. What is the ratio of the Aid flow (current US$) in United Kingdom in 1964 to that in 1965?
Make the answer very short. 1.07. What is the ratio of the Aid flow (current US$) of United States in 1964 to that in 1965?
Keep it short and to the point. 0.8. What is the ratio of the Aid flow (current US$) in Iceland in 1964 to that in 1965?
Your answer should be compact. 0.61. What is the ratio of the Aid flow (current US$) in European Union in 1964 to that in 1966?
Give a very brief answer. 0.76. What is the ratio of the Aid flow (current US$) in United States in 1964 to that in 1966?
Ensure brevity in your answer.  0.94. What is the ratio of the Aid flow (current US$) of Iceland in 1964 to that in 1966?
Provide a short and direct response. 0.38. What is the ratio of the Aid flow (current US$) of European Union in 1964 to that in 1967?
Provide a succinct answer. 0.82. What is the ratio of the Aid flow (current US$) of United Kingdom in 1964 to that in 1967?
Provide a succinct answer. 1.05. What is the ratio of the Aid flow (current US$) of United States in 1964 to that in 1967?
Provide a short and direct response. 0.99. What is the ratio of the Aid flow (current US$) of Iceland in 1964 to that in 1967?
Your response must be concise. 0.43. What is the ratio of the Aid flow (current US$) in European Union in 1965 to that in 1966?
Ensure brevity in your answer.  0.88. What is the ratio of the Aid flow (current US$) in United Kingdom in 1965 to that in 1966?
Give a very brief answer. 0.93. What is the ratio of the Aid flow (current US$) in United States in 1965 to that in 1966?
Keep it short and to the point. 1.18. What is the ratio of the Aid flow (current US$) in Iceland in 1965 to that in 1966?
Your answer should be very brief. 0.63. What is the ratio of the Aid flow (current US$) of European Union in 1965 to that in 1967?
Offer a very short reply. 0.96. What is the ratio of the Aid flow (current US$) in United Kingdom in 1965 to that in 1967?
Your answer should be compact. 0.98. What is the ratio of the Aid flow (current US$) of United States in 1965 to that in 1967?
Provide a succinct answer. 1.24. What is the ratio of the Aid flow (current US$) in Iceland in 1965 to that in 1967?
Keep it short and to the point. 0.7. What is the ratio of the Aid flow (current US$) in European Union in 1966 to that in 1967?
Offer a very short reply. 1.08. What is the ratio of the Aid flow (current US$) in United Kingdom in 1966 to that in 1967?
Keep it short and to the point. 1.05. What is the ratio of the Aid flow (current US$) of United States in 1966 to that in 1967?
Ensure brevity in your answer.  1.05. What is the ratio of the Aid flow (current US$) of Iceland in 1966 to that in 1967?
Offer a very short reply. 1.11. What is the difference between the highest and the second highest Aid flow (current US$) in European Union?
Provide a succinct answer. 5.35e+06. What is the difference between the highest and the second highest Aid flow (current US$) in United Kingdom?
Give a very brief answer. 2.10e+05. What is the difference between the highest and the second highest Aid flow (current US$) in United States?
Provide a succinct answer. 2.17e+07. What is the difference between the highest and the lowest Aid flow (current US$) in European Union?
Your answer should be very brief. 3.36e+07. What is the difference between the highest and the lowest Aid flow (current US$) in United Kingdom?
Keep it short and to the point. 4.42e+07. What is the difference between the highest and the lowest Aid flow (current US$) in United States?
Keep it short and to the point. 5.77e+07. What is the difference between the highest and the lowest Aid flow (current US$) of Iceland?
Ensure brevity in your answer.  2.63e+06. 